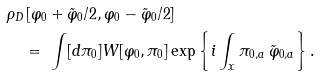<formula> <loc_0><loc_0><loc_500><loc_500>& \rho _ { D } \left [ \varphi _ { 0 } + { \tilde { \varphi } } _ { 0 } / 2 , \varphi _ { 0 } - { \tilde { \varphi } } _ { 0 } / 2 \right ] \\ & \quad = \ \int [ d \pi _ { 0 } ] W [ \varphi _ { 0 } , \pi _ { 0 } ] \exp \left \{ i \int _ { x } \pi _ { 0 , a } \, \tilde { \varphi } _ { 0 , a } \right \} .</formula> 